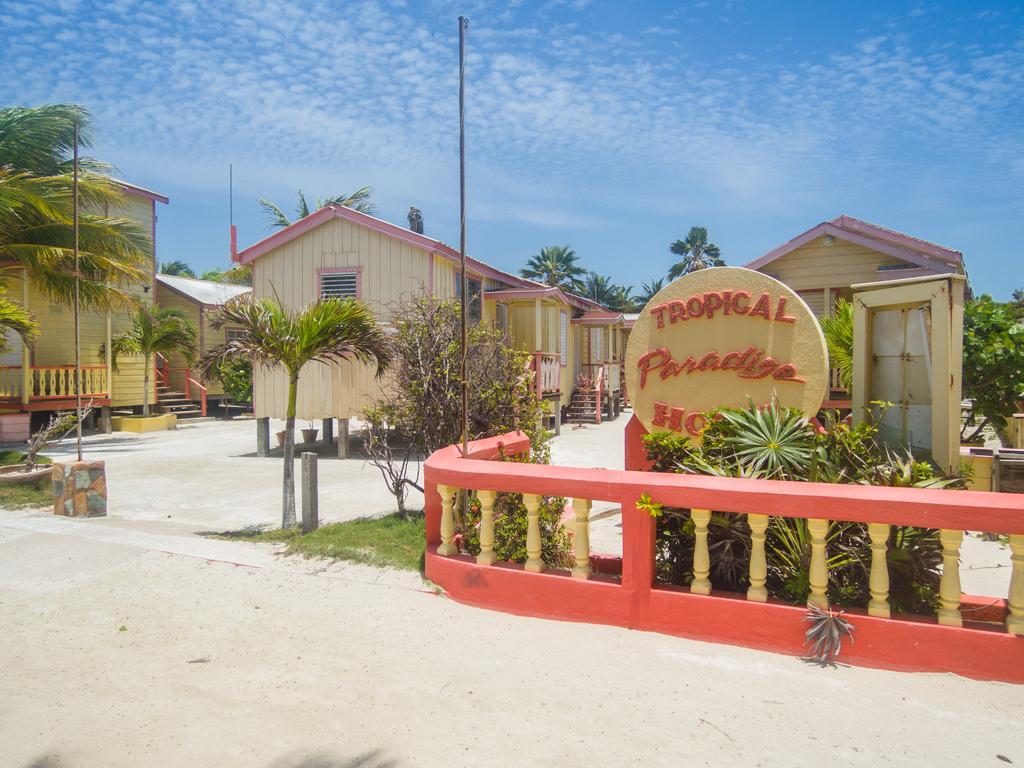Please provide a concise description of this image. In this image, there is an outside view. In the foreground, there are some plants and sheds. There is a board in the middle of the image. In the background, there is a sky. 